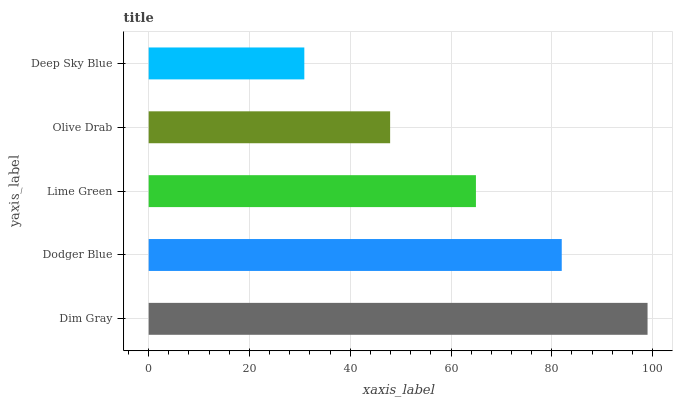Is Deep Sky Blue the minimum?
Answer yes or no. Yes. Is Dim Gray the maximum?
Answer yes or no. Yes. Is Dodger Blue the minimum?
Answer yes or no. No. Is Dodger Blue the maximum?
Answer yes or no. No. Is Dim Gray greater than Dodger Blue?
Answer yes or no. Yes. Is Dodger Blue less than Dim Gray?
Answer yes or no. Yes. Is Dodger Blue greater than Dim Gray?
Answer yes or no. No. Is Dim Gray less than Dodger Blue?
Answer yes or no. No. Is Lime Green the high median?
Answer yes or no. Yes. Is Lime Green the low median?
Answer yes or no. Yes. Is Deep Sky Blue the high median?
Answer yes or no. No. Is Deep Sky Blue the low median?
Answer yes or no. No. 